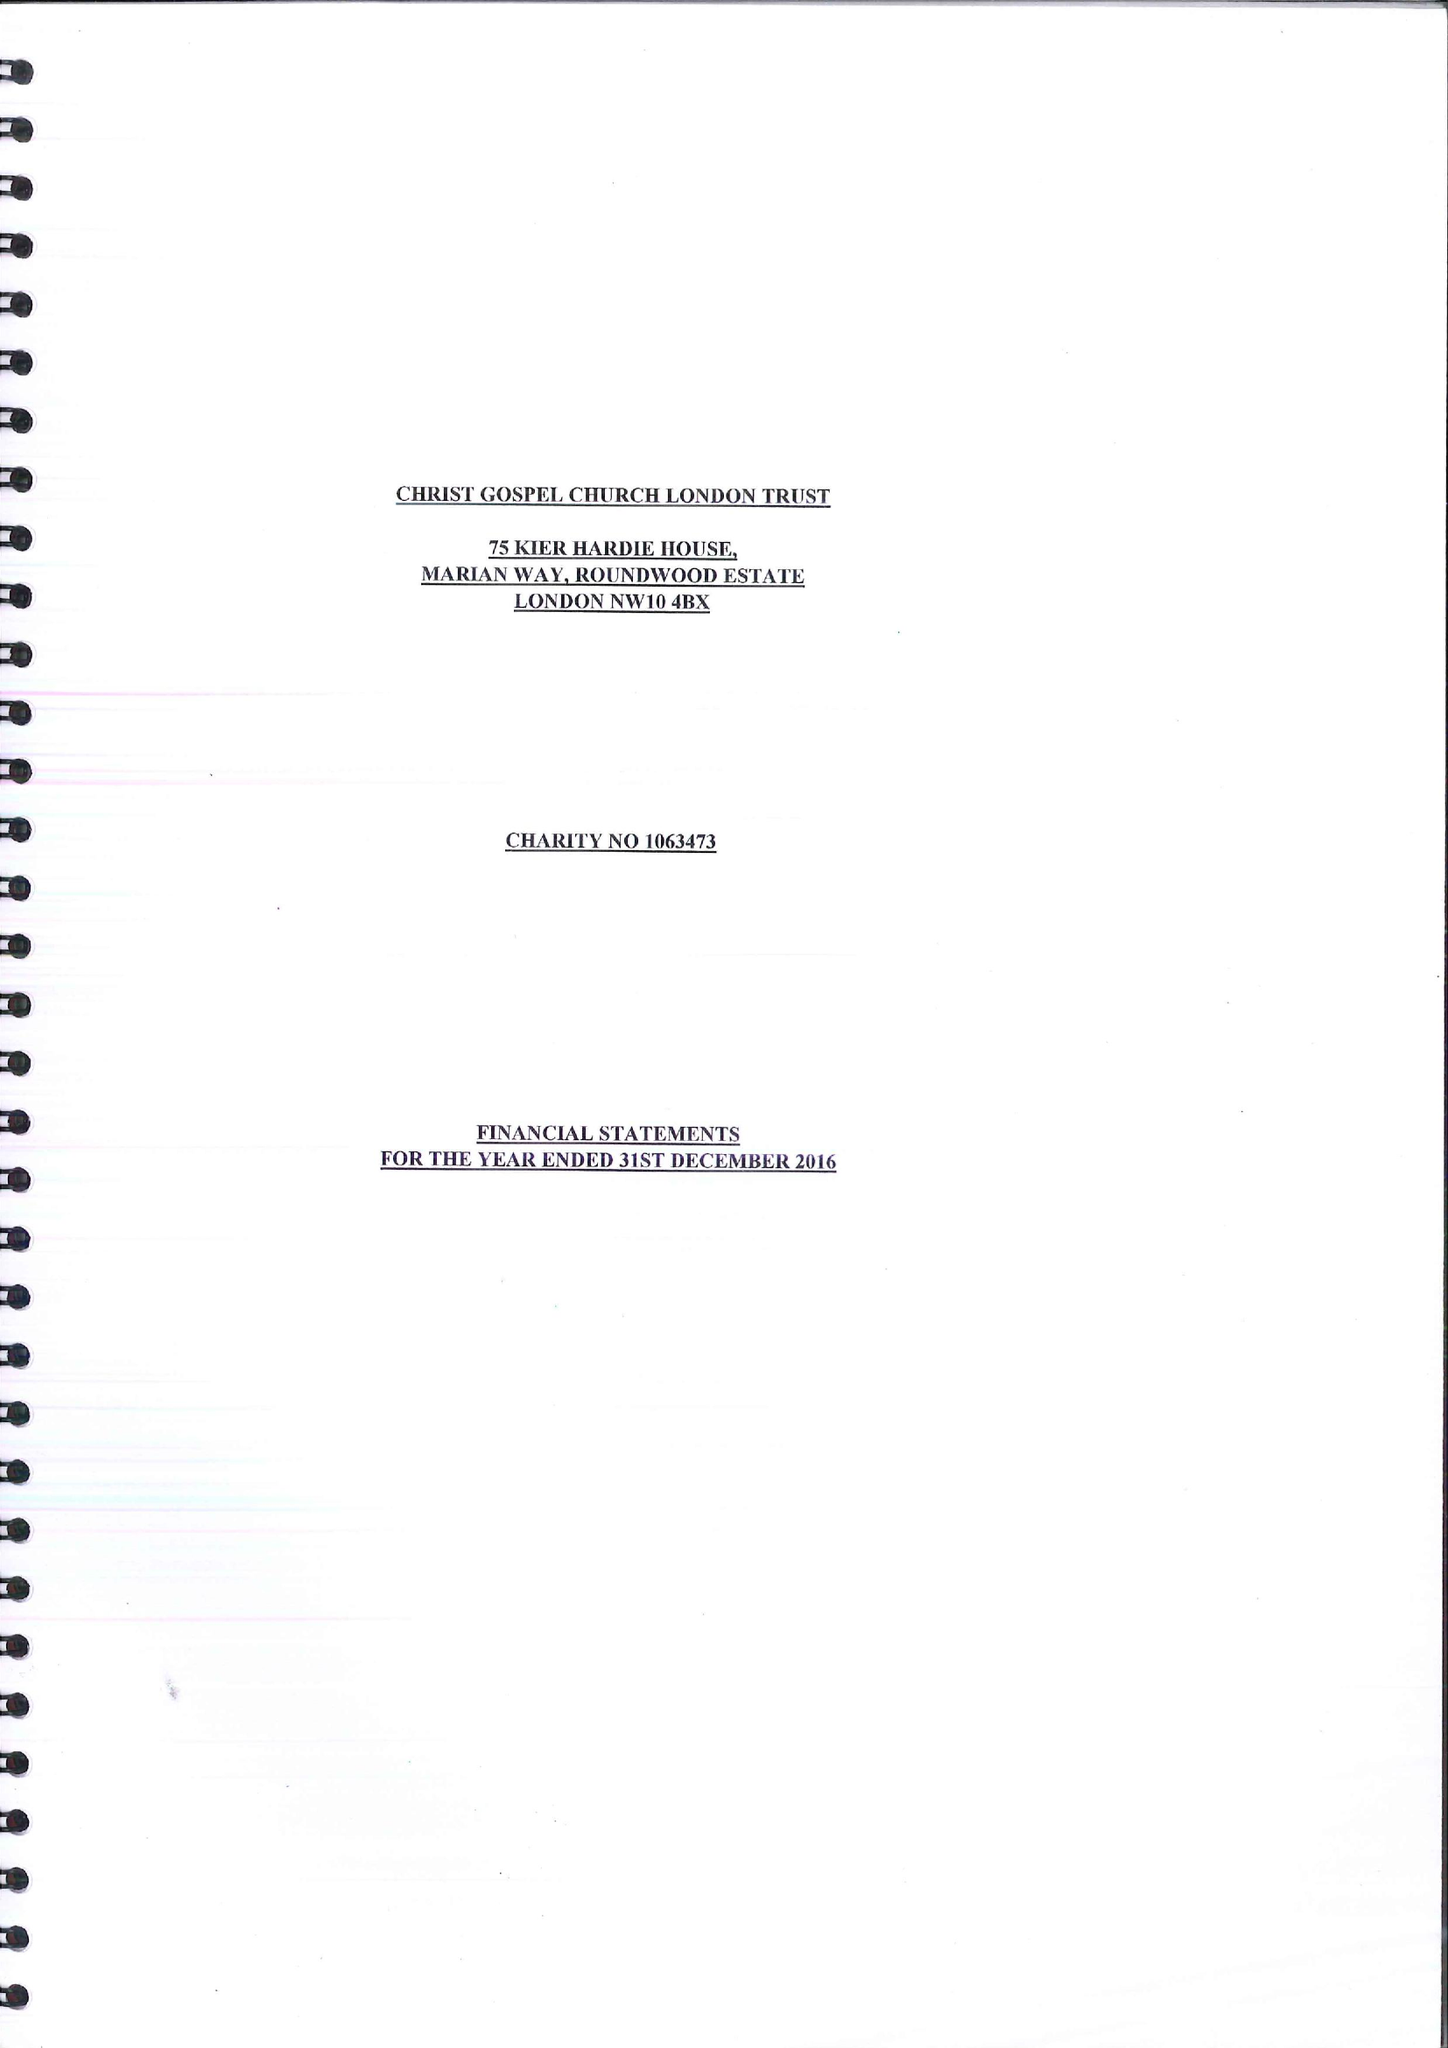What is the value for the address__post_town?
Answer the question using a single word or phrase. LONDON 